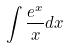<formula> <loc_0><loc_0><loc_500><loc_500>\int \frac { e ^ { x } } { x } d x</formula> 